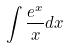<formula> <loc_0><loc_0><loc_500><loc_500>\int \frac { e ^ { x } } { x } d x</formula> 